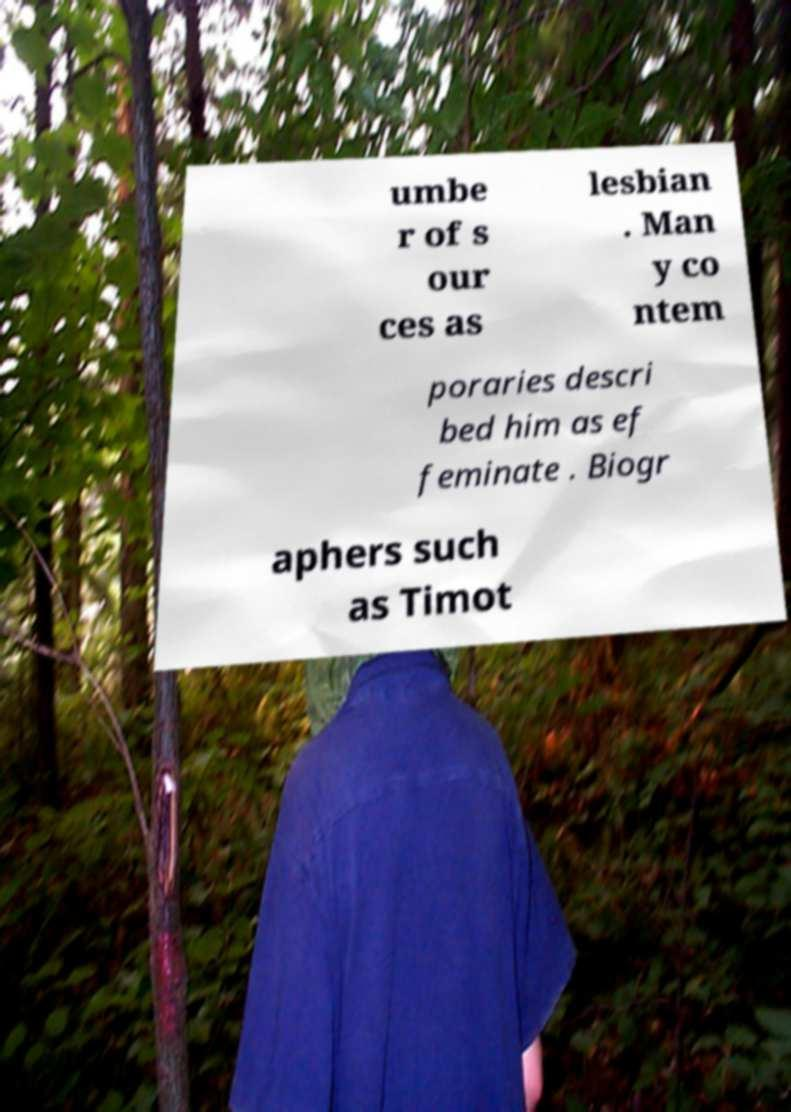Could you extract and type out the text from this image? umbe r of s our ces as lesbian . Man y co ntem poraries descri bed him as ef feminate . Biogr aphers such as Timot 